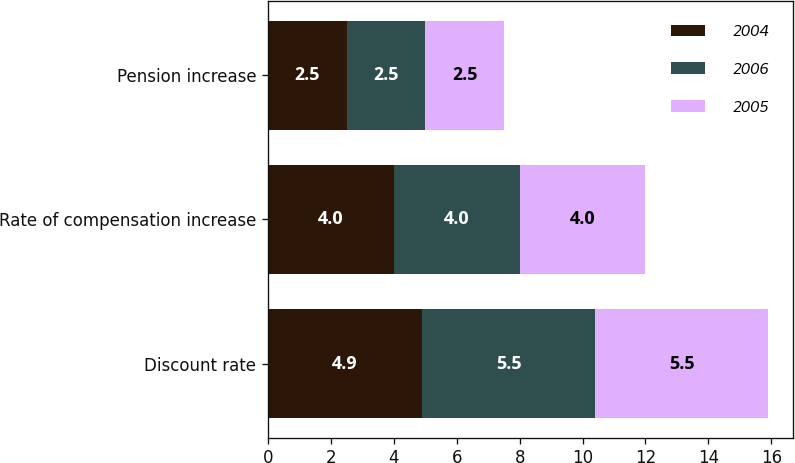<chart> <loc_0><loc_0><loc_500><loc_500><stacked_bar_chart><ecel><fcel>Discount rate<fcel>Rate of compensation increase<fcel>Pension increase<nl><fcel>2004<fcel>4.9<fcel>4<fcel>2.5<nl><fcel>2006<fcel>5.5<fcel>4<fcel>2.5<nl><fcel>2005<fcel>5.5<fcel>4<fcel>2.5<nl></chart> 